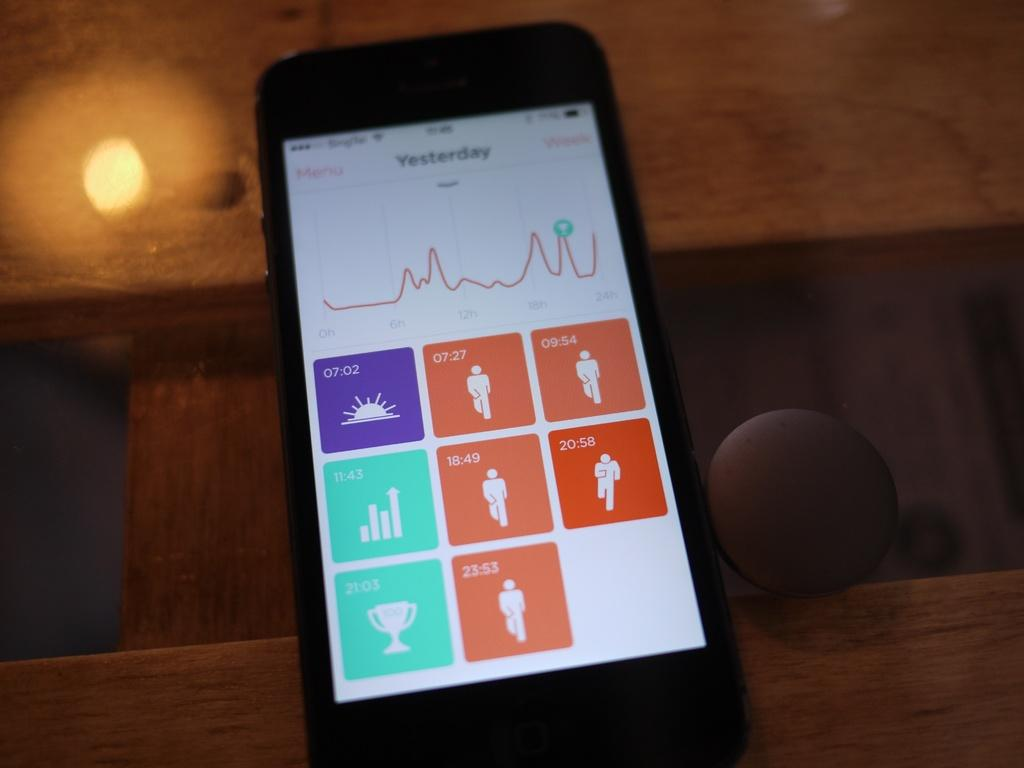<image>
Present a compact description of the photo's key features. A black smartphone showing the fitness activity of yesterday the phone is on a brown irregular surface. 